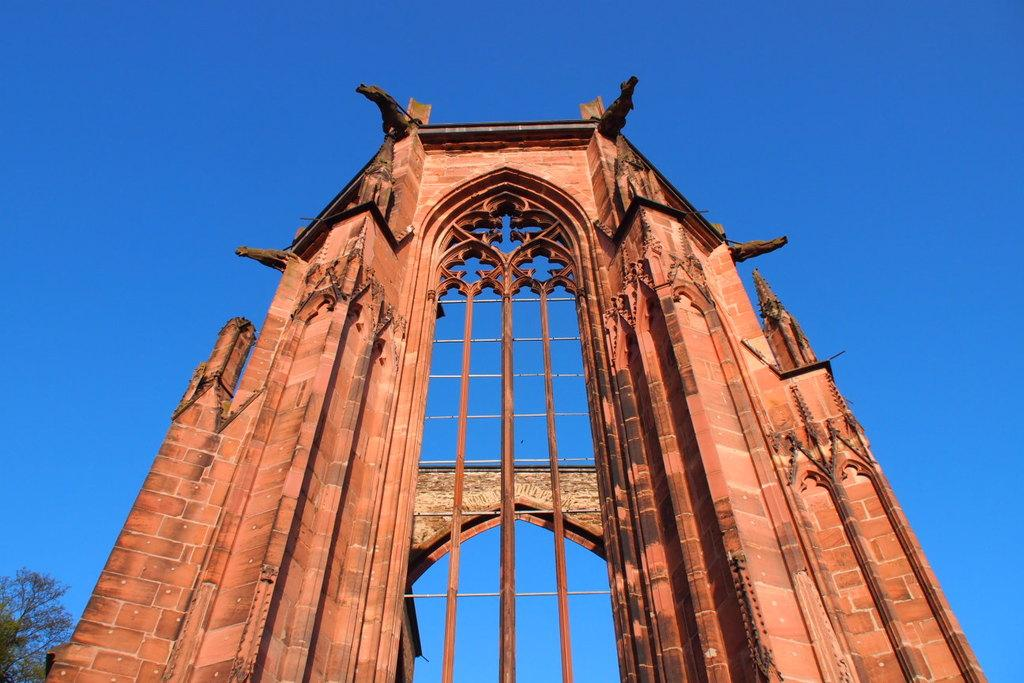What type of structure is present in the image? There is a stone arch in the image. What can be seen on the left side of the image? There is a tree on the left side of the image. What color is the sky in the background of the image? The sky in the background of the image is blue. What type of gold ornaments are hanging from the branches of the tree in the image? There are no gold ornaments present in the image; the tree is not adorned with any decorations. 